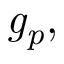Convert formula to latex. <formula><loc_0><loc_0><loc_500><loc_500>{ g _ { p } } ,</formula> 